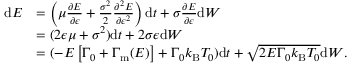Convert formula to latex. <formula><loc_0><loc_0><loc_500><loc_500>\begin{array} { r l } { d E } & { = \left ( \mu \frac { \partial E } { \partial \epsilon } + \frac { \sigma ^ { 2 } } { 2 } \frac { \partial ^ { 2 } E } { \partial \epsilon ^ { 2 } } \right ) d t + \sigma \frac { \partial E } { \partial \epsilon } d { W } } \\ & { = ( 2 \epsilon \mu + \sigma ^ { 2 } ) d t + 2 \sigma \epsilon d { W } } \\ & { = ( - E \left [ { \Gamma _ { 0 } + \Gamma _ { m } ( E ) } \right ] + { \Gamma _ { 0 } k _ { B } T _ { 0 } } ) d t + \sqrt { 2 E \Gamma _ { 0 } k _ { B } T _ { 0 } } d { W } . } \end{array}</formula> 